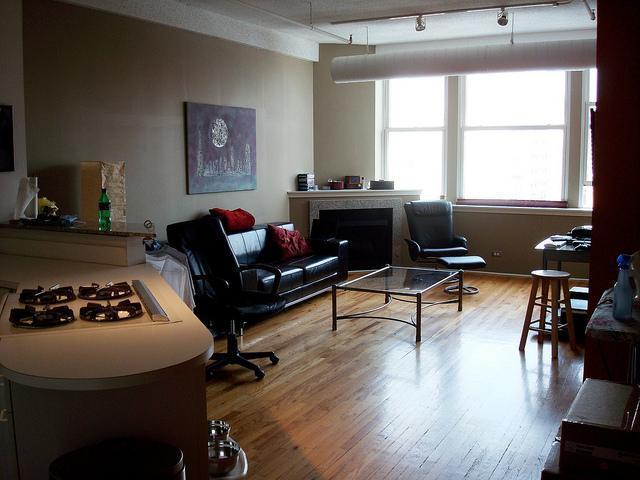How many pictures are on the wall?
Give a very brief answer. 1. How many framed objects?
Give a very brief answer. 1. How many chairs are there?
Give a very brief answer. 3. 